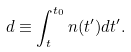Convert formula to latex. <formula><loc_0><loc_0><loc_500><loc_500>d \equiv \int ^ { t _ { 0 } } _ { t } n ( t ^ { \prime } ) d t ^ { \prime } .</formula> 